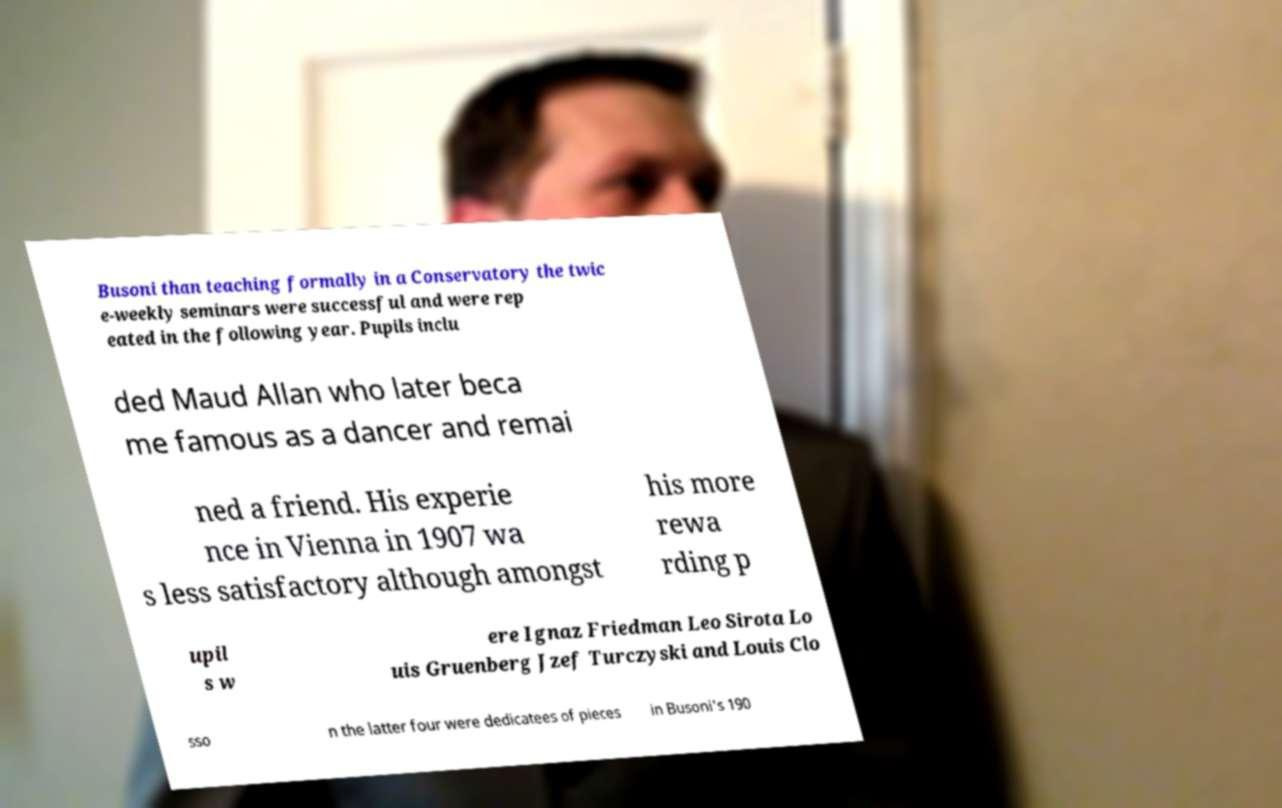I need the written content from this picture converted into text. Can you do that? Busoni than teaching formally in a Conservatory the twic e-weekly seminars were successful and were rep eated in the following year. Pupils inclu ded Maud Allan who later beca me famous as a dancer and remai ned a friend. His experie nce in Vienna in 1907 wa s less satisfactory although amongst his more rewa rding p upil s w ere Ignaz Friedman Leo Sirota Lo uis Gruenberg Jzef Turczyski and Louis Clo sso n the latter four were dedicatees of pieces in Busoni's 190 